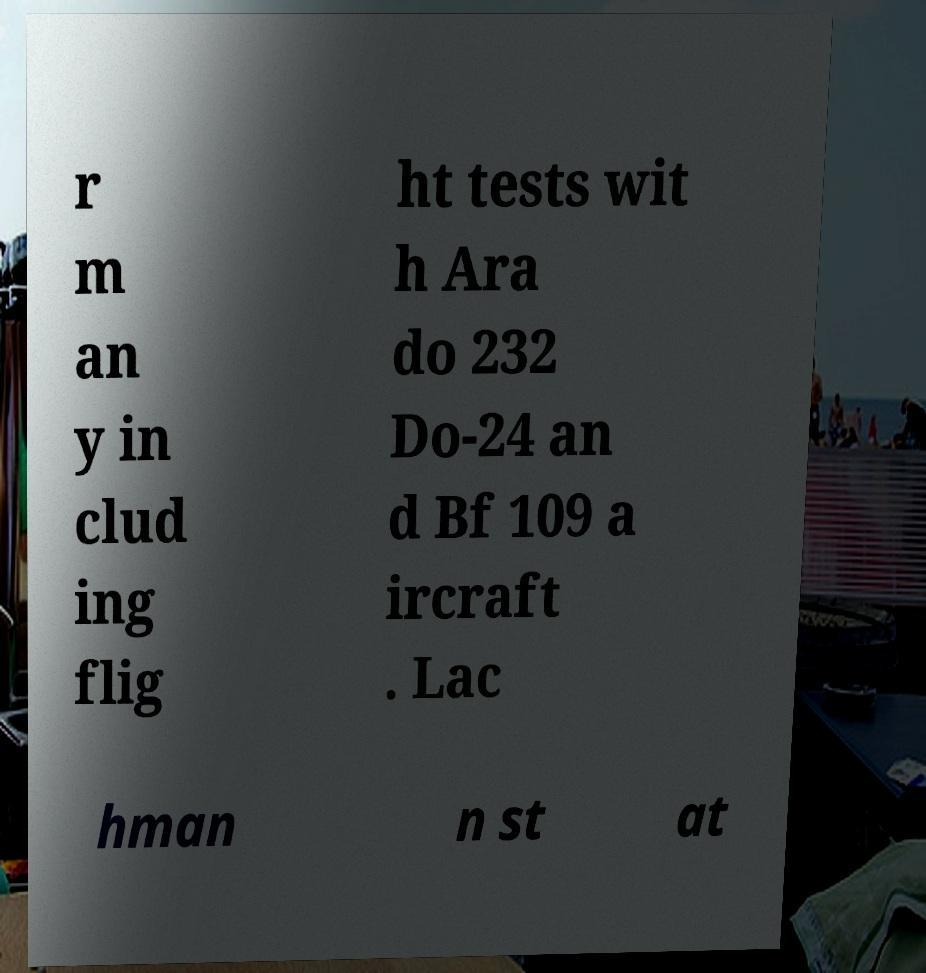Could you extract and type out the text from this image? r m an y in clud ing flig ht tests wit h Ara do 232 Do-24 an d Bf 109 a ircraft . Lac hman n st at 